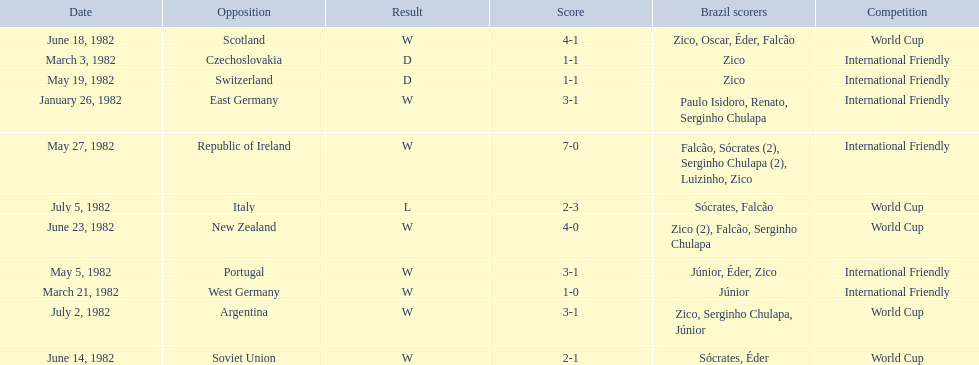What are the dates January 26, 1982, March 3, 1982, March 21, 1982, May 5, 1982, May 19, 1982, May 27, 1982, June 14, 1982, June 18, 1982, June 23, 1982, July 2, 1982, July 5, 1982. Which date is at the top? January 26, 1982. 